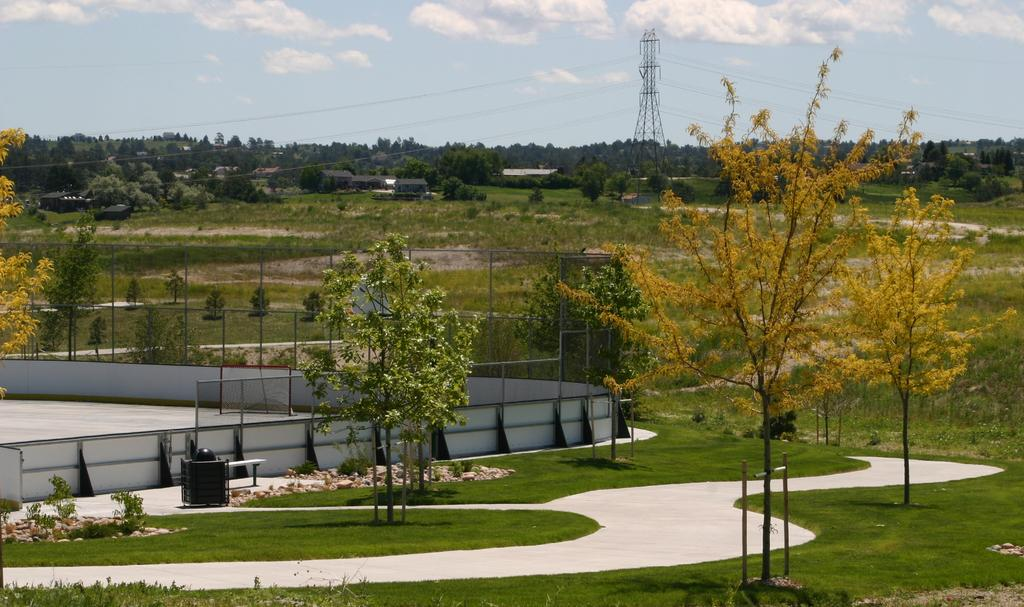What type of structure can be seen in the image? There is fencing in the image. What is the main object in the foreground of the image? There is a tank in the image. What is the terrain like in the image? There is grassy land in the image. What type of vegetation is present in the image? There are trees in the image. What can be seen in the background of the image? The background of the image includes a tower and more trees. What else is present in the background of the image? Wires are present in the background of the image. What is visible at the top of the image? The sky is visible at the top of the image. What can be seen in the sky? Clouds are present in the sky. How many baby cars are visible in the image? There are no baby cars present in the image. What type of wool is being used to create the tower in the image? There is no wool present in the image, and the tower is not being created; it is a pre-existing structure. 